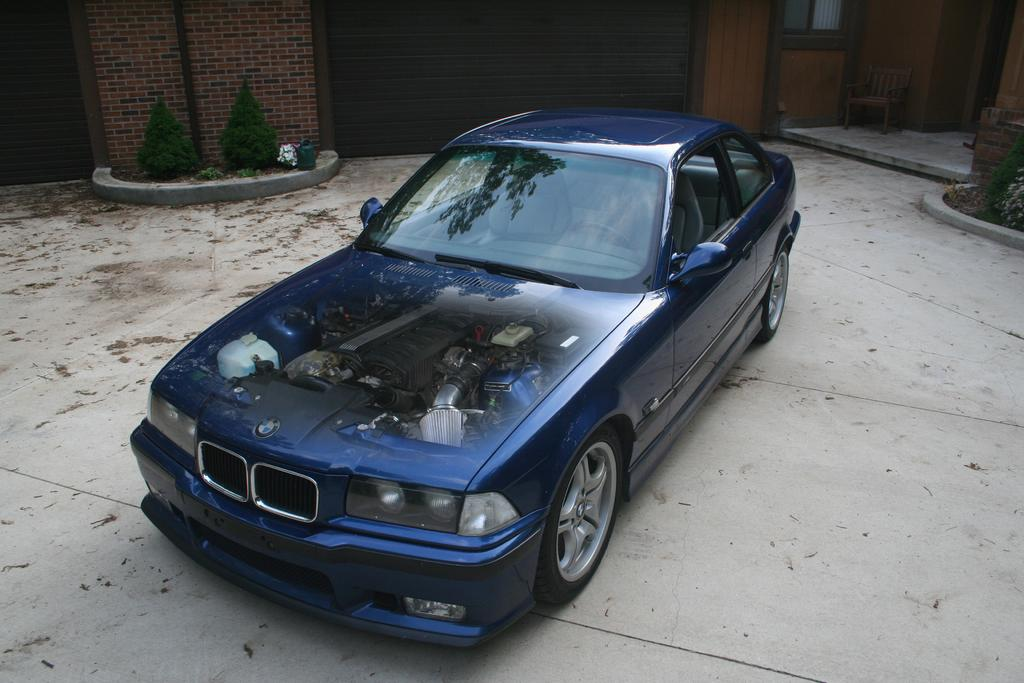What is the main subject in the picture? There is a vehicle in the picture. What can be seen in the background of the picture? There is a building, a chair, plants, and other objects in the background of the picture. Can you describe the building in the background? Unfortunately, the facts provided do not give enough detail to describe the building in the background. What type of market is being represented in the image? There is no market present in the image, so it cannot be represented. 